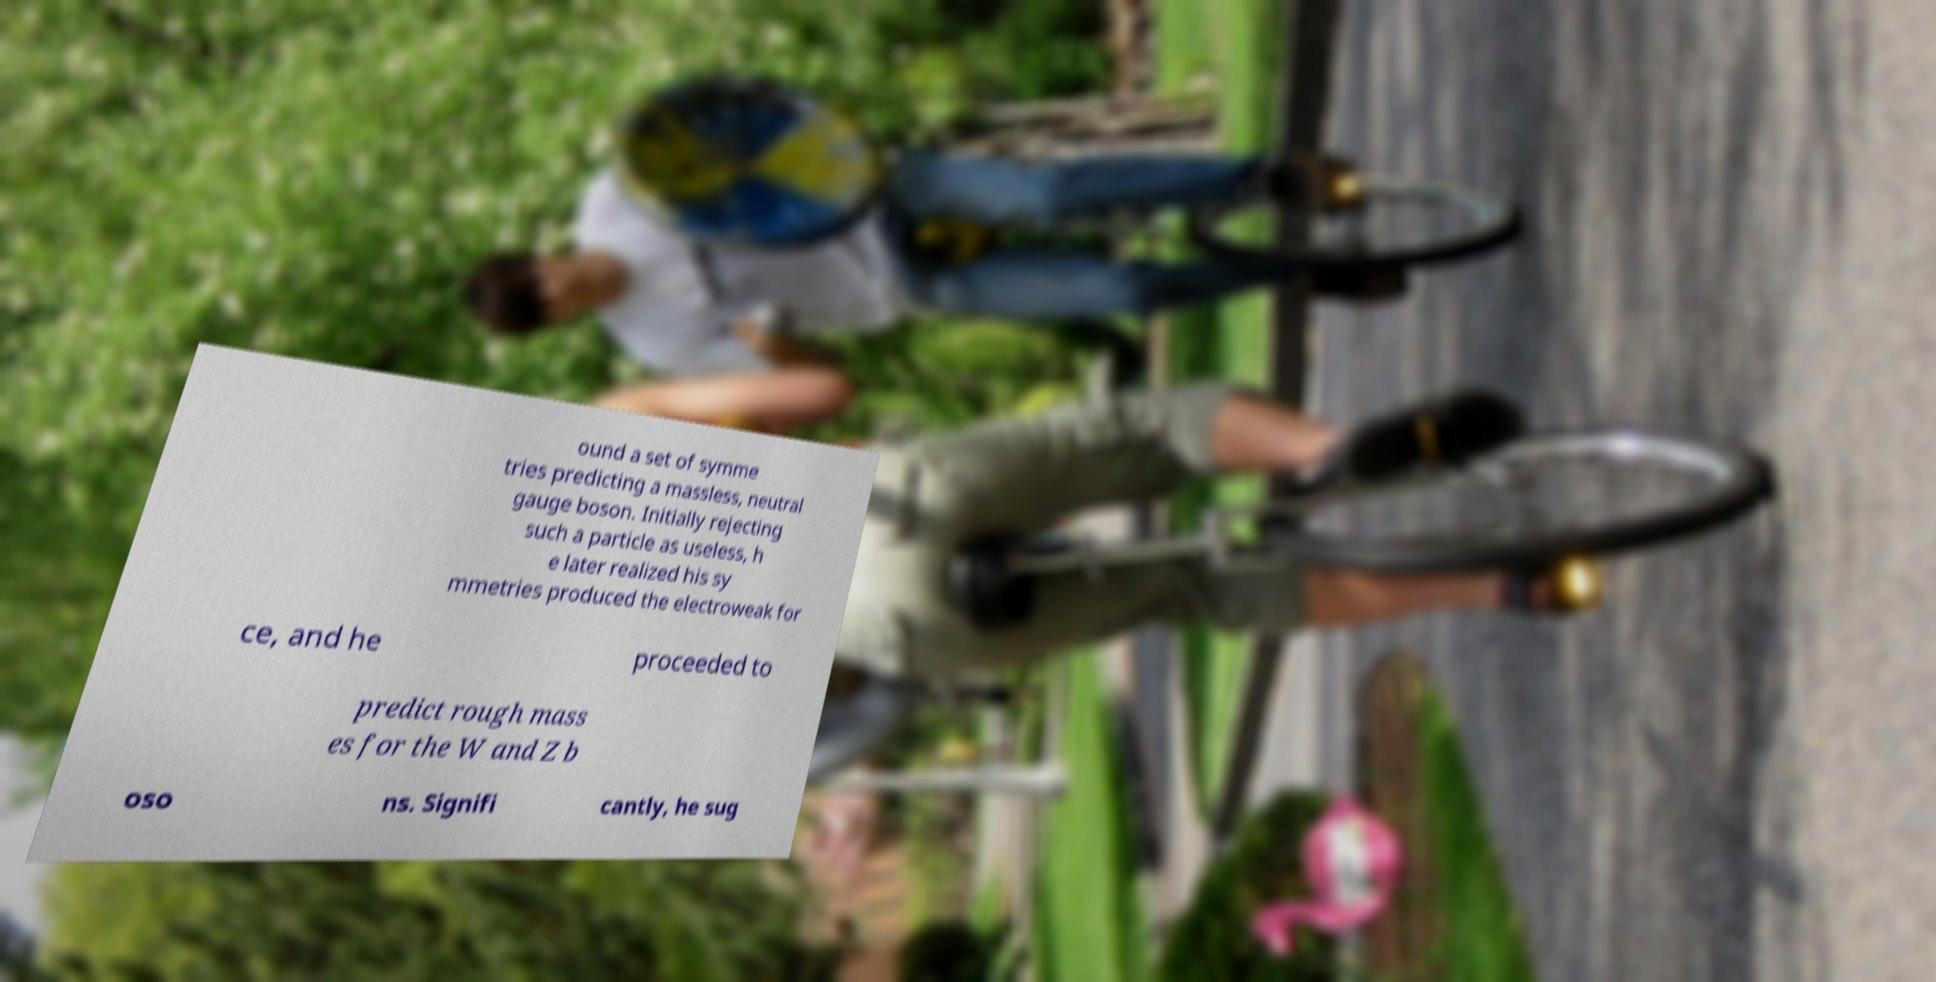For documentation purposes, I need the text within this image transcribed. Could you provide that? ound a set of symme tries predicting a massless, neutral gauge boson. Initially rejecting such a particle as useless, h e later realized his sy mmetries produced the electroweak for ce, and he proceeded to predict rough mass es for the W and Z b oso ns. Signifi cantly, he sug 